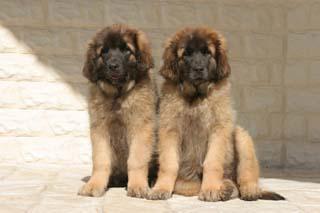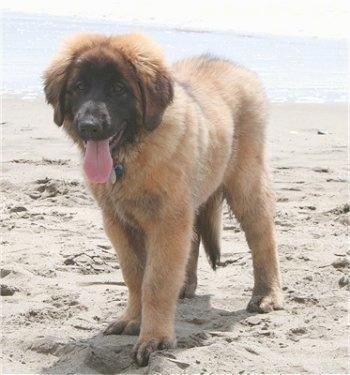The first image is the image on the left, the second image is the image on the right. Analyze the images presented: Is the assertion "Only one dog is sitting in the grass." valid? Answer yes or no. No. The first image is the image on the left, the second image is the image on the right. Given the left and right images, does the statement "two puppies are atanding next to each other on the grass looking upward" hold true? Answer yes or no. No. 